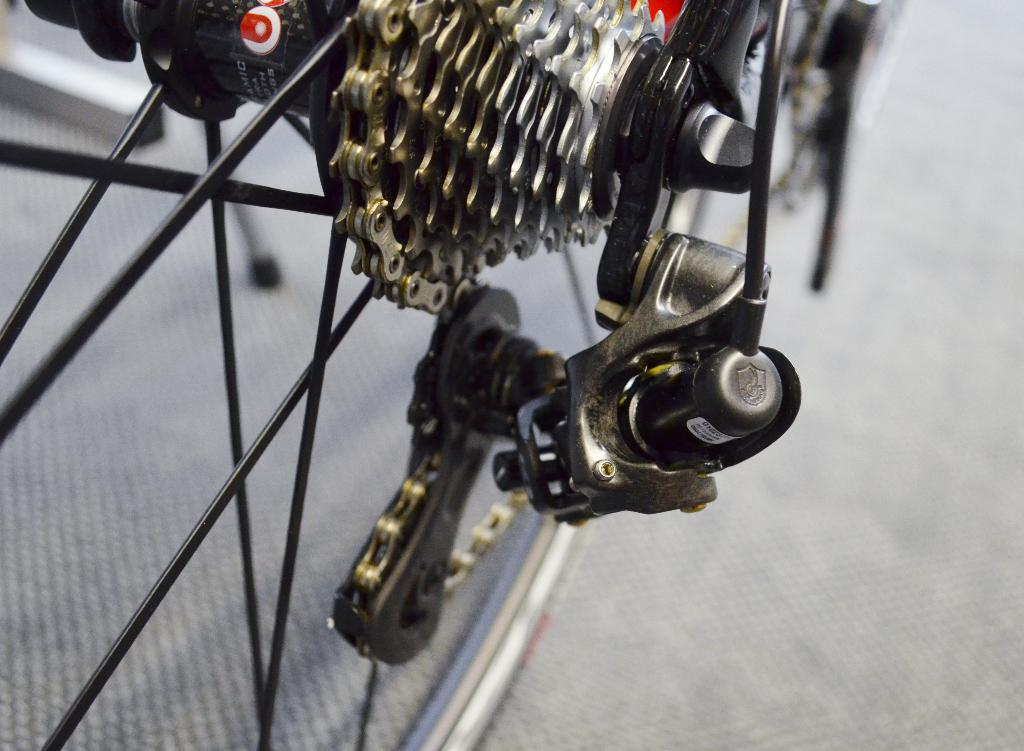What is the main subject of the picture? The main subject of the picture is a bicycle. Can you describe the background of the image? The background of the image is blurry. What specific parts of the bicycle can be seen in the image? The spokes and chain of the bicycle are visible. How many clocks are hanging on the bicycle in the image? There are no clocks present in the image; it features a bicycle with visible spokes and chain. What type of stick is being used to ride the bicycle in the image? There is no stick being used to ride the bicycle in the image; it is a regular bicycle. 